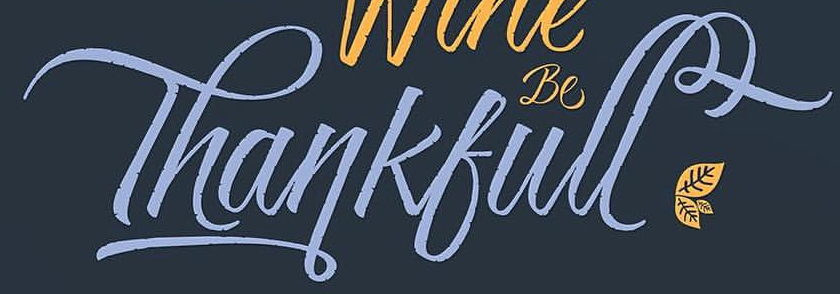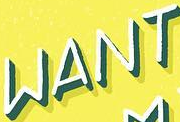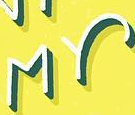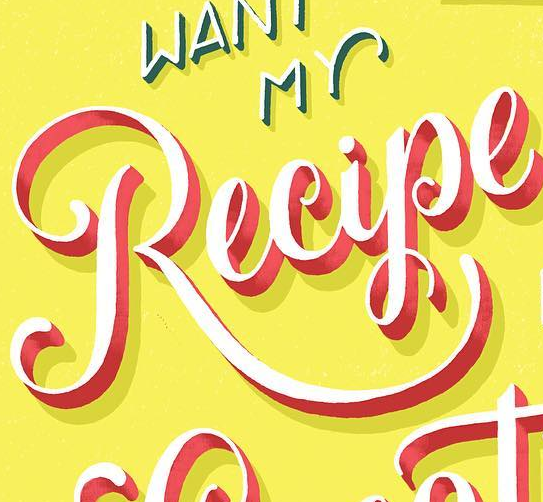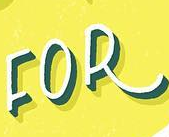What words can you see in these images in sequence, separated by a semicolon? Thankfull; WANT; MY; Recipe; FOR 